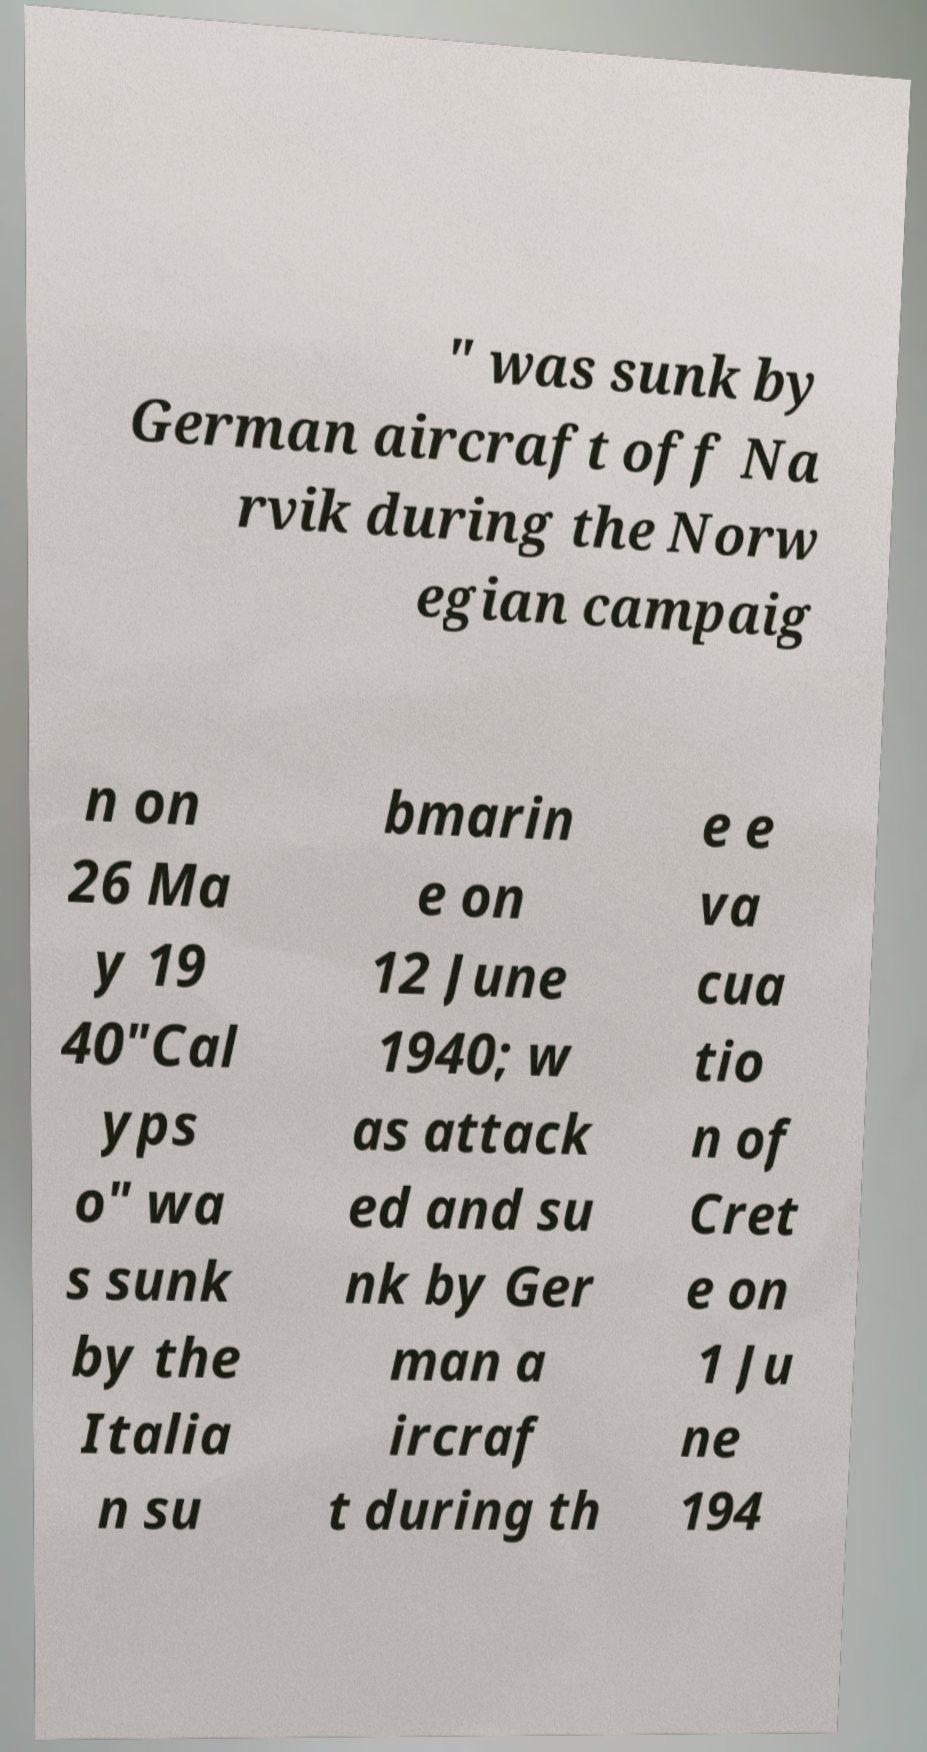What messages or text are displayed in this image? I need them in a readable, typed format. " was sunk by German aircraft off Na rvik during the Norw egian campaig n on 26 Ma y 19 40"Cal yps o" wa s sunk by the Italia n su bmarin e on 12 June 1940; w as attack ed and su nk by Ger man a ircraf t during th e e va cua tio n of Cret e on 1 Ju ne 194 